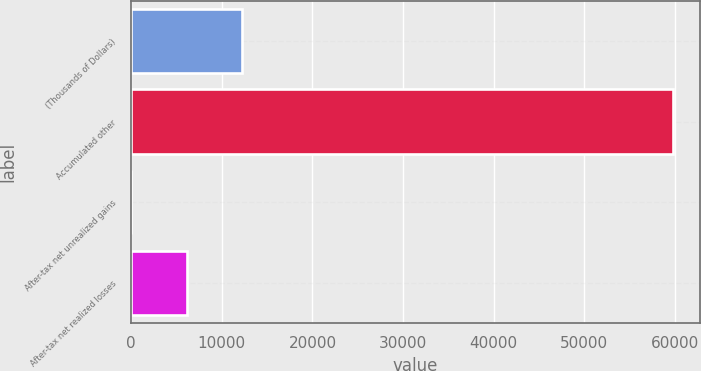Convert chart to OTSL. <chart><loc_0><loc_0><loc_500><loc_500><bar_chart><fcel>(Thousands of Dollars)<fcel>Accumulated other<fcel>After-tax net unrealized gains<fcel>After-tax net realized losses<nl><fcel>12257.8<fcel>59753<fcel>12<fcel>6134.9<nl></chart> 